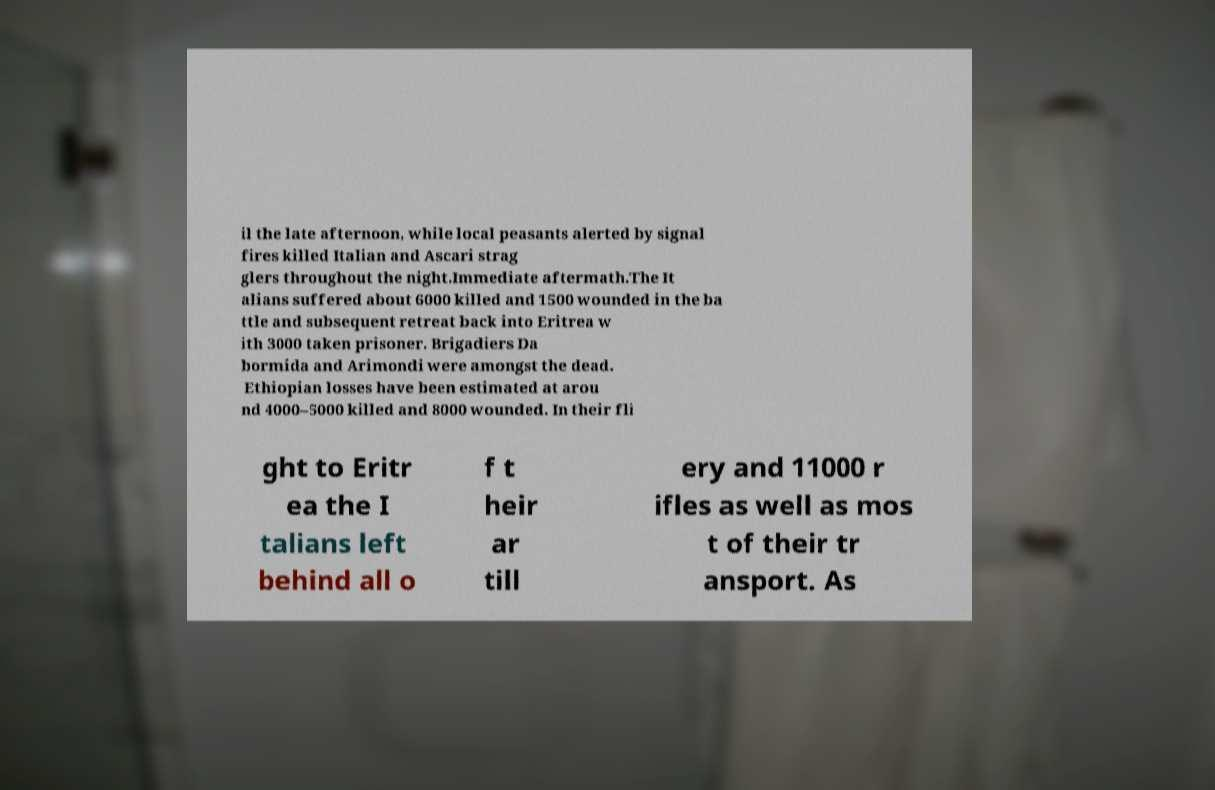I need the written content from this picture converted into text. Can you do that? il the late afternoon, while local peasants alerted by signal fires killed Italian and Ascari strag glers throughout the night.Immediate aftermath.The It alians suffered about 6000 killed and 1500 wounded in the ba ttle and subsequent retreat back into Eritrea w ith 3000 taken prisoner. Brigadiers Da bormida and Arimondi were amongst the dead. Ethiopian losses have been estimated at arou nd 4000–5000 killed and 8000 wounded. In their fli ght to Eritr ea the I talians left behind all o f t heir ar till ery and 11000 r ifles as well as mos t of their tr ansport. As 